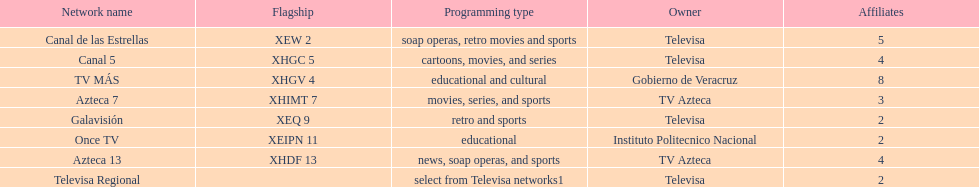Tell me the number of stations tv azteca owns. 2. 